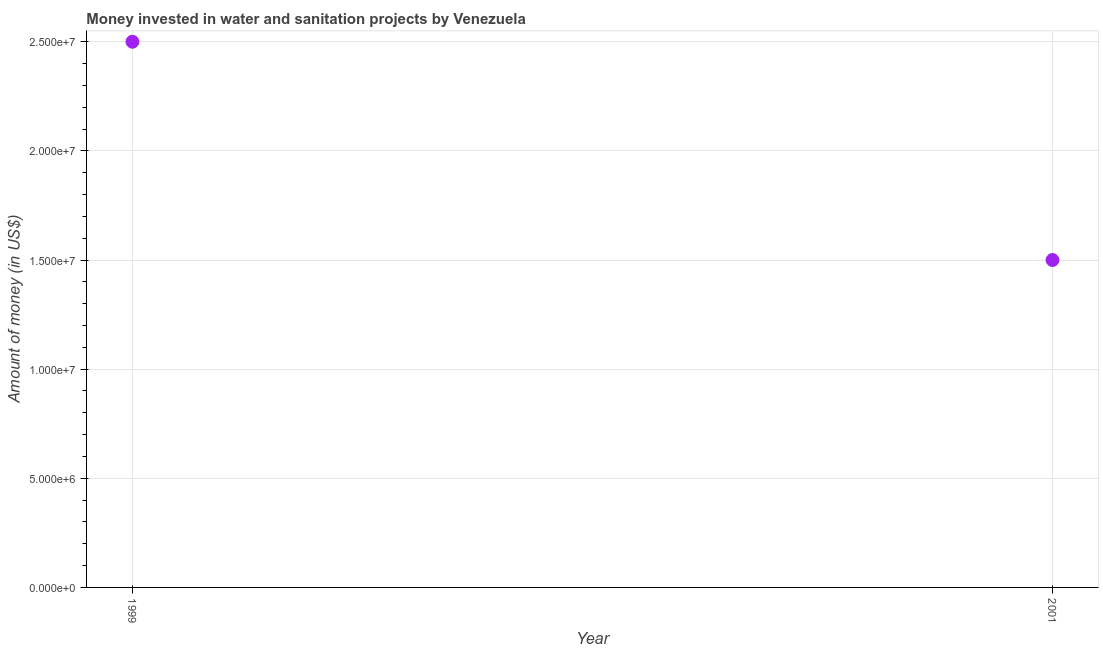What is the investment in 1999?
Your response must be concise. 2.50e+07. Across all years, what is the maximum investment?
Your answer should be very brief. 2.50e+07. Across all years, what is the minimum investment?
Your answer should be compact. 1.50e+07. In which year was the investment maximum?
Offer a very short reply. 1999. In which year was the investment minimum?
Offer a terse response. 2001. What is the sum of the investment?
Your answer should be compact. 4.00e+07. What is the difference between the investment in 1999 and 2001?
Your answer should be very brief. 1.00e+07. What is the average investment per year?
Give a very brief answer. 2.00e+07. In how many years, is the investment greater than 4000000 US$?
Make the answer very short. 2. Do a majority of the years between 2001 and 1999 (inclusive) have investment greater than 1000000 US$?
Offer a terse response. No. What is the ratio of the investment in 1999 to that in 2001?
Give a very brief answer. 1.67. In how many years, is the investment greater than the average investment taken over all years?
Your answer should be very brief. 1. Does the investment monotonically increase over the years?
Give a very brief answer. No. What is the difference between two consecutive major ticks on the Y-axis?
Ensure brevity in your answer.  5.00e+06. Are the values on the major ticks of Y-axis written in scientific E-notation?
Provide a short and direct response. Yes. Does the graph contain any zero values?
Your answer should be very brief. No. What is the title of the graph?
Ensure brevity in your answer.  Money invested in water and sanitation projects by Venezuela. What is the label or title of the Y-axis?
Your answer should be compact. Amount of money (in US$). What is the Amount of money (in US$) in 1999?
Your answer should be very brief. 2.50e+07. What is the Amount of money (in US$) in 2001?
Your answer should be compact. 1.50e+07. What is the difference between the Amount of money (in US$) in 1999 and 2001?
Your response must be concise. 1.00e+07. What is the ratio of the Amount of money (in US$) in 1999 to that in 2001?
Give a very brief answer. 1.67. 